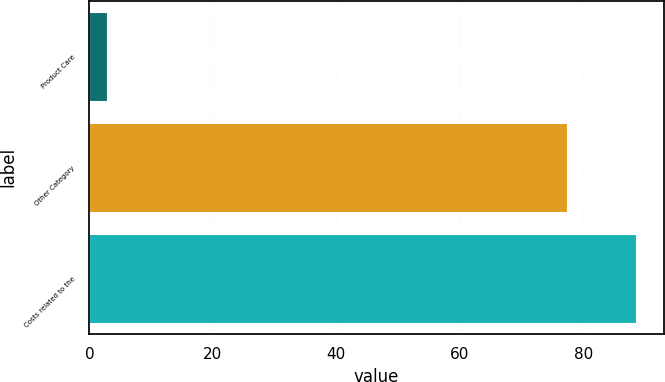<chart> <loc_0><loc_0><loc_500><loc_500><bar_chart><fcel>Product Care<fcel>Other Category<fcel>Costs related to the<nl><fcel>2.9<fcel>77.3<fcel>88.6<nl></chart> 